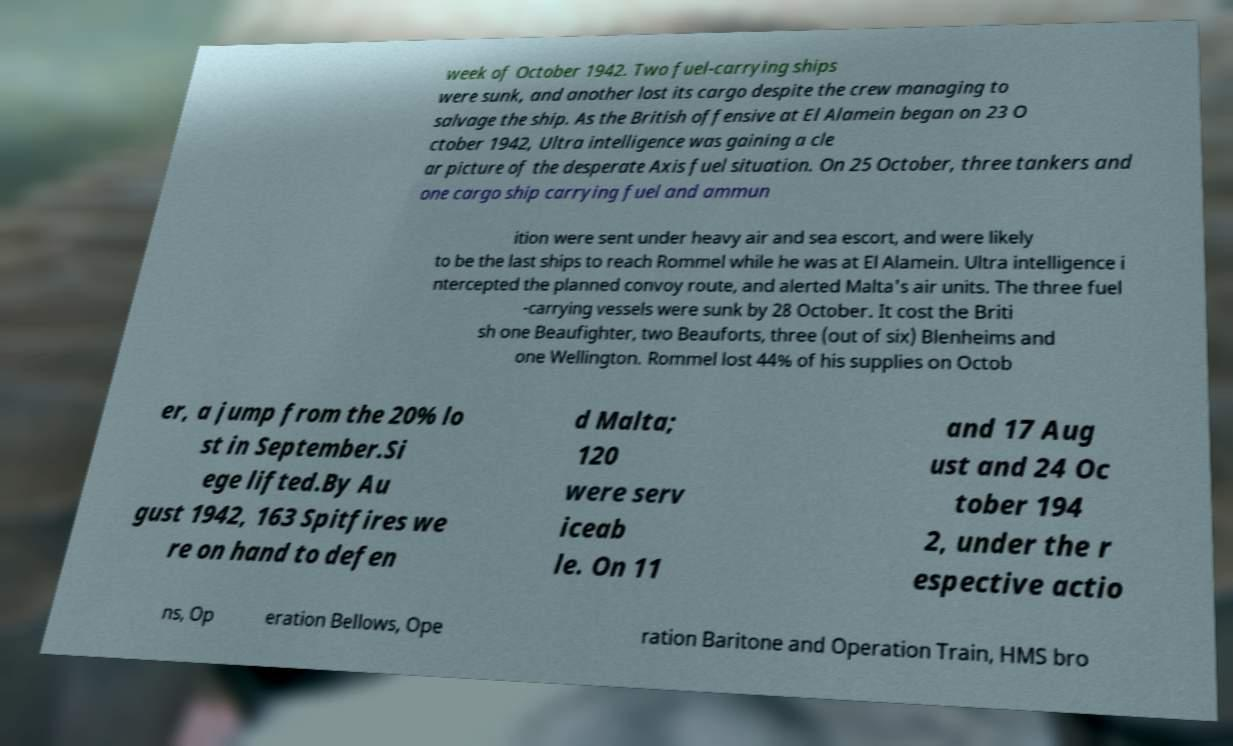Could you extract and type out the text from this image? week of October 1942. Two fuel-carrying ships were sunk, and another lost its cargo despite the crew managing to salvage the ship. As the British offensive at El Alamein began on 23 O ctober 1942, Ultra intelligence was gaining a cle ar picture of the desperate Axis fuel situation. On 25 October, three tankers and one cargo ship carrying fuel and ammun ition were sent under heavy air and sea escort, and were likely to be the last ships to reach Rommel while he was at El Alamein. Ultra intelligence i ntercepted the planned convoy route, and alerted Malta's air units. The three fuel -carrying vessels were sunk by 28 October. It cost the Briti sh one Beaufighter, two Beauforts, three (out of six) Blenheims and one Wellington. Rommel lost 44% of his supplies on Octob er, a jump from the 20% lo st in September.Si ege lifted.By Au gust 1942, 163 Spitfires we re on hand to defen d Malta; 120 were serv iceab le. On 11 and 17 Aug ust and 24 Oc tober 194 2, under the r espective actio ns, Op eration Bellows, Ope ration Baritone and Operation Train, HMS bro 